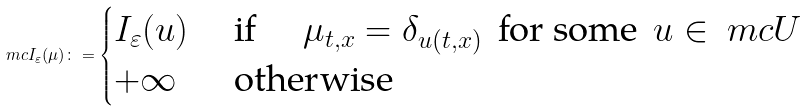Convert formula to latex. <formula><loc_0><loc_0><loc_500><loc_500>\ m c I _ { \varepsilon } ( \mu ) \colon = \begin{cases} I _ { \varepsilon } ( u ) & \text { if } \quad \mu _ { t , x } = \delta _ { u ( t , x ) } \, \text { for some } \, u \in \ m c U \\ + \infty & \text { otherwise } \end{cases}</formula> 